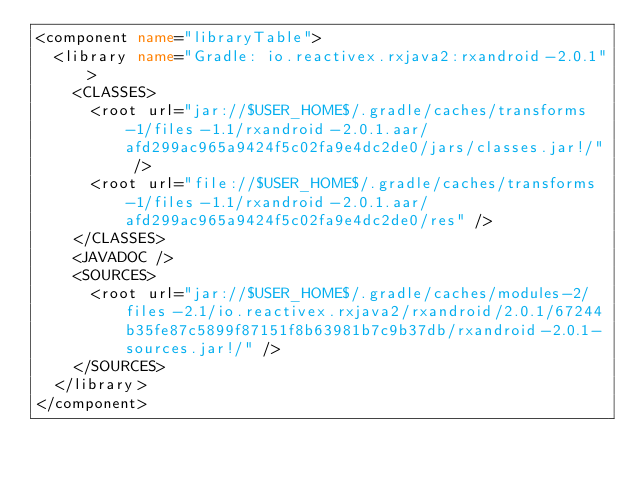Convert code to text. <code><loc_0><loc_0><loc_500><loc_500><_XML_><component name="libraryTable">
  <library name="Gradle: io.reactivex.rxjava2:rxandroid-2.0.1">
    <CLASSES>
      <root url="jar://$USER_HOME$/.gradle/caches/transforms-1/files-1.1/rxandroid-2.0.1.aar/afd299ac965a9424f5c02fa9e4dc2de0/jars/classes.jar!/" />
      <root url="file://$USER_HOME$/.gradle/caches/transforms-1/files-1.1/rxandroid-2.0.1.aar/afd299ac965a9424f5c02fa9e4dc2de0/res" />
    </CLASSES>
    <JAVADOC />
    <SOURCES>
      <root url="jar://$USER_HOME$/.gradle/caches/modules-2/files-2.1/io.reactivex.rxjava2/rxandroid/2.0.1/67244b35fe87c5899f87151f8b63981b7c9b37db/rxandroid-2.0.1-sources.jar!/" />
    </SOURCES>
  </library>
</component></code> 